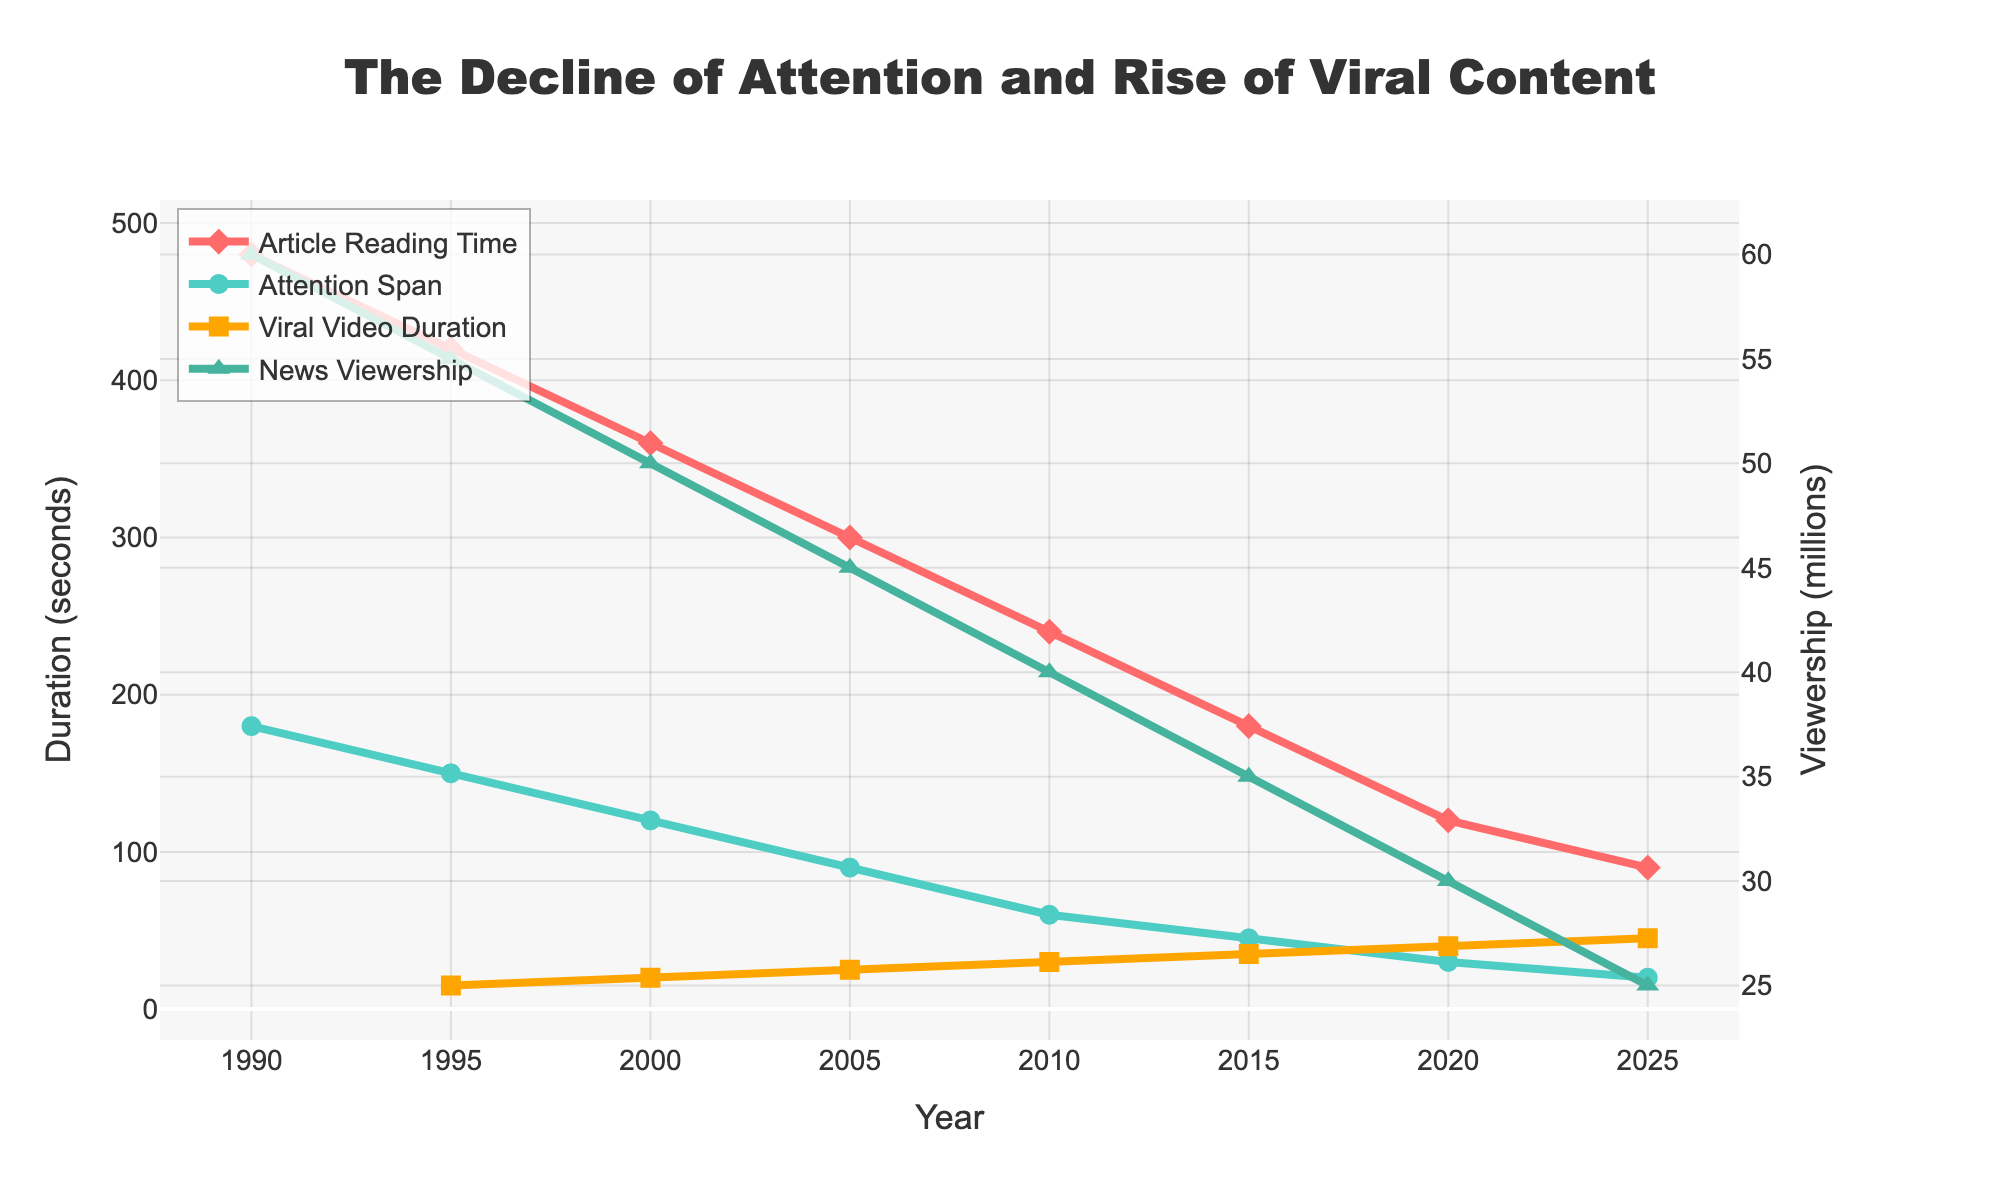What's the trend in Average Article Reading Time from 1990 to 2025? The line representing Average Article Reading Time shows a downward slope from 480 seconds in 1990 to 90 seconds in 2025. This indicates a consistent decrease in the time people spend reading articles over the years.
Answer: Decreasing Compare the change in Traditional News Viewership and Average Attention Span between 1990 and 2025. The figures show Traditional News Viewership declining from 60 million in 1990 to 25 million in 2025 and Average Attention Span decreasing from 180 seconds to 20 seconds. Both metrics show a downward trend, but the decrease in Attention Span is more drastic.
Answer: Both decreased, Attention Span more drastically Which year had the highest value for Viral Video View Duration, and what was its duration? The highest value for Viral Video View Duration occurred in 2025, with a duration of 45 seconds. This can be observed where the orange line reaches its peak.
Answer: 2025, 45 seconds By how many seconds did Average Article Reading Time decrease from 2000 to 2010? In 2000, Average Article Reading Time was 360 seconds, and in 2010 it was 240 seconds. The difference is 360 - 240 = 120 seconds.
Answer: 120 seconds Between which two years did Traditional News Viewership experience the largest decline? The largest decline can be observed between 2010 and 2015, where Traditional News Viewership dropped from 40 million to 35 million, a difference of 5 million. This is the steepest drop compared to other years.
Answer: 2010-2015 What is the relationship between Viral Video View Duration and Average Attention Span in 2020? In 2020, Viral Video View Duration was 40 seconds, while Average Attention Span was 30 seconds. Viral Video View Duration is greater than Average Attention Span in 2020.
Answer: Viral Video View Duration > Average Attention Span How does the 2025 value of Average Attention Span compare with the 1990 value? Average Attention Span in 2025 is 20 seconds, significantly lower than the 180 seconds recorded in 1990. This indicates a substantial decrease over the years.
Answer: Much lower What pattern can be observed from the changes in Average Article Reading Time and Viral Video View Duration from 1990 to 2025? Average Article Reading Time consistently decreases, while Viral Video View Duration increases over the years. The two trends are inversely related, with one going down while the other goes up.
Answer: Inverse relationship 